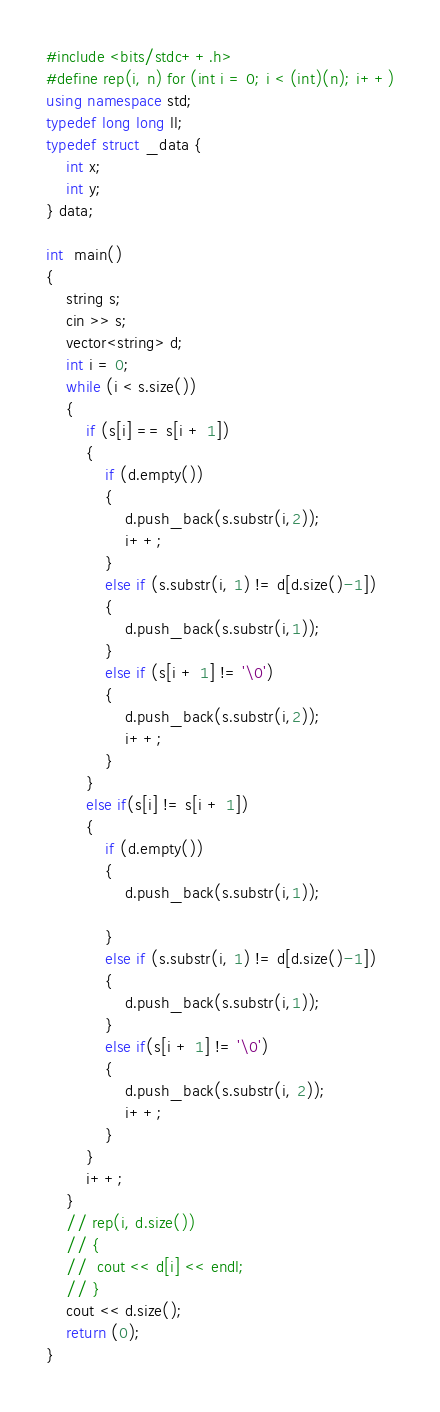<code> <loc_0><loc_0><loc_500><loc_500><_C++_>#include <bits/stdc++.h>
#define rep(i, n) for (int i = 0; i < (int)(n); i++)
using namespace std;
typedef long long ll;
typedef struct _data {
	int x;
	int y;
} data;

int  main()
{
	string s;
	cin >> s;
	vector<string> d;
	int i = 0;
	while (i < s.size())
	{
		if (s[i] == s[i + 1])
		{
			if (d.empty())
			{
				d.push_back(s.substr(i,2));
				i++;
			}
			else if (s.substr(i, 1) != d[d.size()-1])
			{
				d.push_back(s.substr(i,1));
			}
			else if (s[i + 1] != '\0')
			{
				d.push_back(s.substr(i,2));
				i++;
			}
		}
		else if(s[i] != s[i + 1])
		{
			if (d.empty())
			{
				d.push_back(s.substr(i,1));

			}
			else if (s.substr(i, 1) != d[d.size()-1])
			{
				d.push_back(s.substr(i,1));
			}
			else if(s[i + 1] != '\0')
			{
				d.push_back(s.substr(i, 2));
				i++;
			}
		}
		i++;
	}
	// rep(i, d.size())
	// {
	// 	cout << d[i] << endl;
	// }
	cout << d.size();
	return (0);
}
</code> 